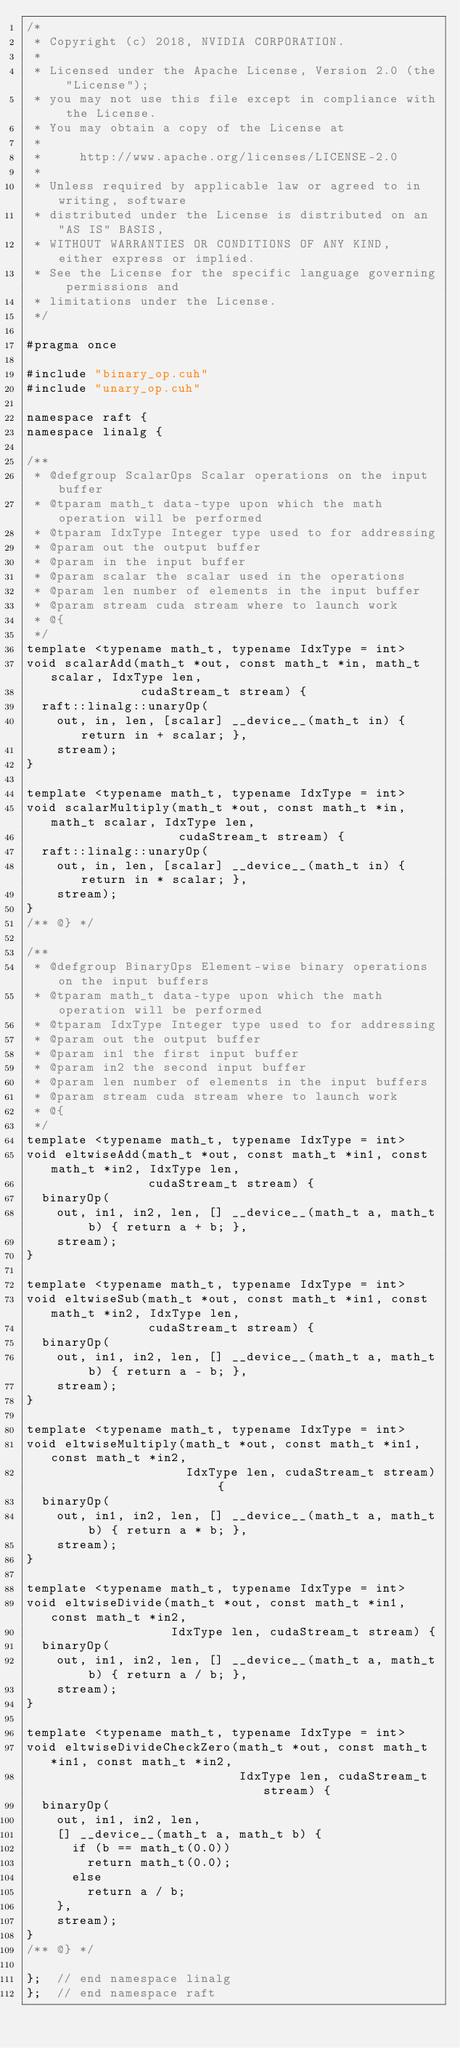<code> <loc_0><loc_0><loc_500><loc_500><_Cuda_>/*
 * Copyright (c) 2018, NVIDIA CORPORATION.
 *
 * Licensed under the Apache License, Version 2.0 (the "License");
 * you may not use this file except in compliance with the License.
 * You may obtain a copy of the License at
 *
 *     http://www.apache.org/licenses/LICENSE-2.0
 *
 * Unless required by applicable law or agreed to in writing, software
 * distributed under the License is distributed on an "AS IS" BASIS,
 * WITHOUT WARRANTIES OR CONDITIONS OF ANY KIND, either express or implied.
 * See the License for the specific language governing permissions and
 * limitations under the License.
 */

#pragma once

#include "binary_op.cuh"
#include "unary_op.cuh"

namespace raft {
namespace linalg {

/**
 * @defgroup ScalarOps Scalar operations on the input buffer
 * @tparam math_t data-type upon which the math operation will be performed
 * @tparam IdxType Integer type used to for addressing
 * @param out the output buffer
 * @param in the input buffer
 * @param scalar the scalar used in the operations
 * @param len number of elements in the input buffer
 * @param stream cuda stream where to launch work
 * @{
 */
template <typename math_t, typename IdxType = int>
void scalarAdd(math_t *out, const math_t *in, math_t scalar, IdxType len,
               cudaStream_t stream) {
  raft::linalg::unaryOp(
    out, in, len, [scalar] __device__(math_t in) { return in + scalar; },
    stream);
}

template <typename math_t, typename IdxType = int>
void scalarMultiply(math_t *out, const math_t *in, math_t scalar, IdxType len,
                    cudaStream_t stream) {
  raft::linalg::unaryOp(
    out, in, len, [scalar] __device__(math_t in) { return in * scalar; },
    stream);
}
/** @} */

/**
 * @defgroup BinaryOps Element-wise binary operations on the input buffers
 * @tparam math_t data-type upon which the math operation will be performed
 * @tparam IdxType Integer type used to for addressing
 * @param out the output buffer
 * @param in1 the first input buffer
 * @param in2 the second input buffer
 * @param len number of elements in the input buffers
 * @param stream cuda stream where to launch work
 * @{
 */
template <typename math_t, typename IdxType = int>
void eltwiseAdd(math_t *out, const math_t *in1, const math_t *in2, IdxType len,
                cudaStream_t stream) {
  binaryOp(
    out, in1, in2, len, [] __device__(math_t a, math_t b) { return a + b; },
    stream);
}

template <typename math_t, typename IdxType = int>
void eltwiseSub(math_t *out, const math_t *in1, const math_t *in2, IdxType len,
                cudaStream_t stream) {
  binaryOp(
    out, in1, in2, len, [] __device__(math_t a, math_t b) { return a - b; },
    stream);
}

template <typename math_t, typename IdxType = int>
void eltwiseMultiply(math_t *out, const math_t *in1, const math_t *in2,
                     IdxType len, cudaStream_t stream) {
  binaryOp(
    out, in1, in2, len, [] __device__(math_t a, math_t b) { return a * b; },
    stream);
}

template <typename math_t, typename IdxType = int>
void eltwiseDivide(math_t *out, const math_t *in1, const math_t *in2,
                   IdxType len, cudaStream_t stream) {
  binaryOp(
    out, in1, in2, len, [] __device__(math_t a, math_t b) { return a / b; },
    stream);
}

template <typename math_t, typename IdxType = int>
void eltwiseDivideCheckZero(math_t *out, const math_t *in1, const math_t *in2,
                            IdxType len, cudaStream_t stream) {
  binaryOp(
    out, in1, in2, len,
    [] __device__(math_t a, math_t b) {
      if (b == math_t(0.0))
        return math_t(0.0);
      else
        return a / b;
    },
    stream);
}
/** @} */

};  // end namespace linalg
};  // end namespace raft
</code> 